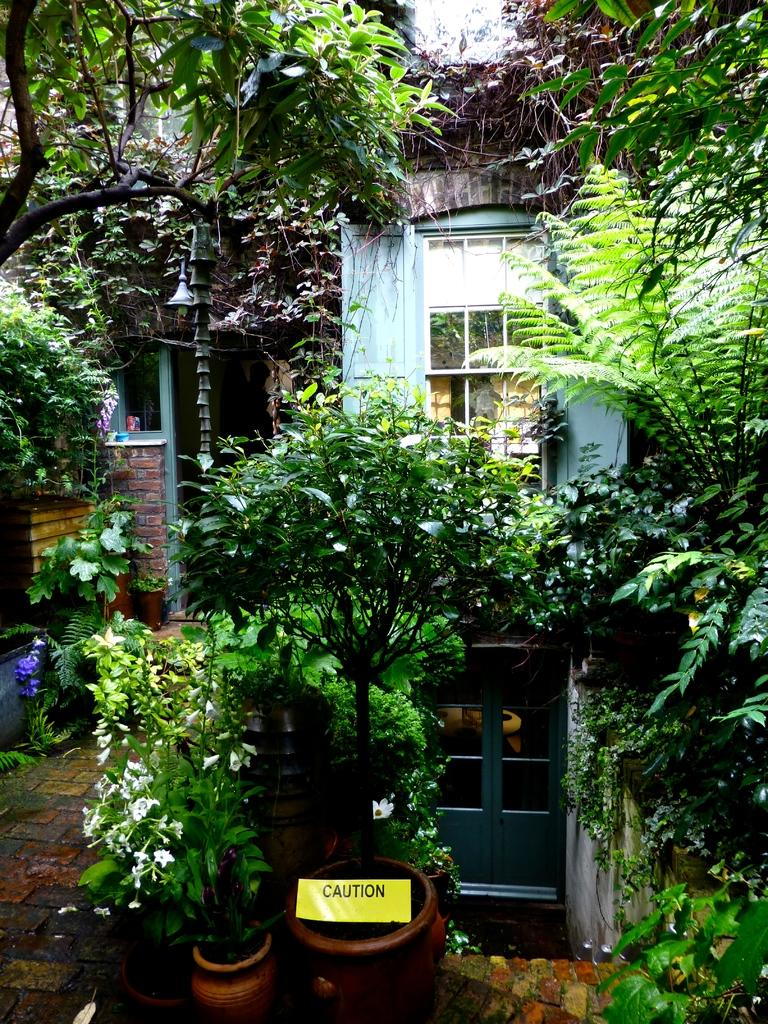What type of structures can be seen in the image? There are buildings in the image. What features can be found on the buildings? There are doors, mirrors, bells, and a sign board visible on the buildings. What is used to support the buildings? There is a pole in the image that might be used to support the buildings. What is the surface on which the buildings stand? There is a floor in the image. What type of vegetation is present in the image? There are house plants and trees in the image. What type of bead is hanging from the roof in the image? There is no bead hanging from the roof in the image, as there is no mention of a roof in the provided facts. 